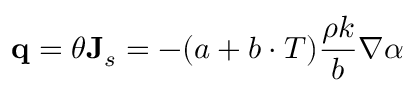Convert formula to latex. <formula><loc_0><loc_0><loc_500><loc_500>\mathbf q = \theta J _ { s } = - ( a + b \cdot T ) \frac { \rho k } { b } \nabla \alpha</formula> 